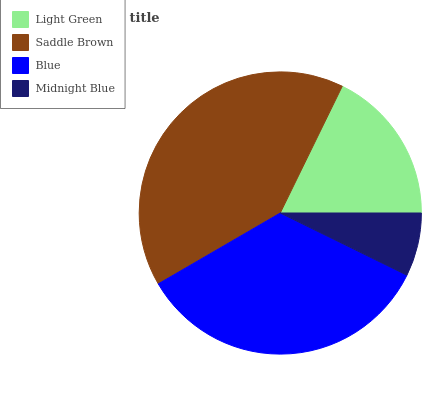Is Midnight Blue the minimum?
Answer yes or no. Yes. Is Saddle Brown the maximum?
Answer yes or no. Yes. Is Blue the minimum?
Answer yes or no. No. Is Blue the maximum?
Answer yes or no. No. Is Saddle Brown greater than Blue?
Answer yes or no. Yes. Is Blue less than Saddle Brown?
Answer yes or no. Yes. Is Blue greater than Saddle Brown?
Answer yes or no. No. Is Saddle Brown less than Blue?
Answer yes or no. No. Is Blue the high median?
Answer yes or no. Yes. Is Light Green the low median?
Answer yes or no. Yes. Is Midnight Blue the high median?
Answer yes or no. No. Is Midnight Blue the low median?
Answer yes or no. No. 